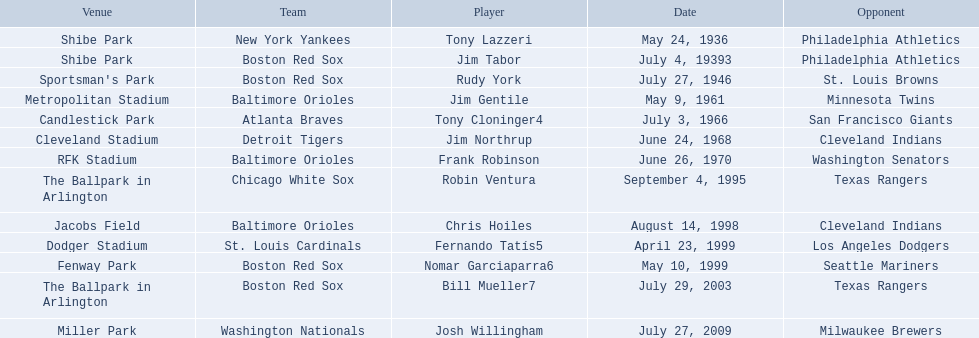Which teams played between the years 1960 and 1970? Baltimore Orioles, Atlanta Braves, Detroit Tigers, Baltimore Orioles. Of these teams that played, which ones played against the cleveland indians? Detroit Tigers. On what day did these two teams play? June 24, 1968. Who are the opponents of the boston red sox during baseball home run records? Philadelphia Athletics, St. Louis Browns, Seattle Mariners, Texas Rangers. Of those which was the opponent on july 27, 1946? St. Louis Browns. 